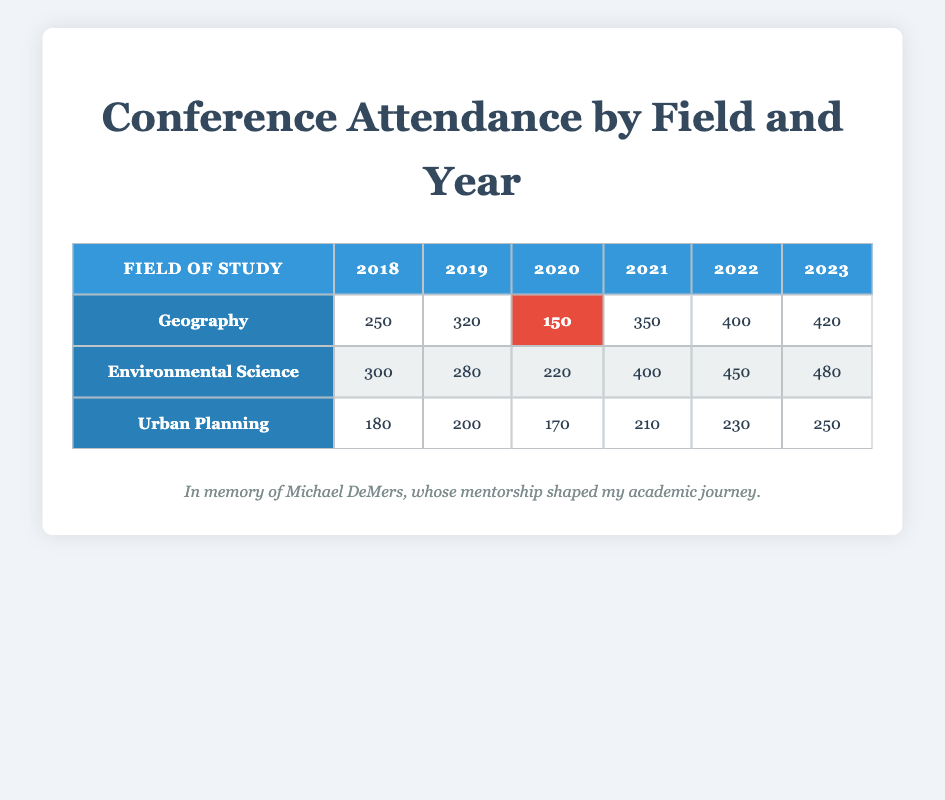What was the conference attendance for Geography in 2021? From the table, we can directly find the attendance for Geography in 2021 in the corresponding row and column which shows 350.
Answer: 350 In which year did Urban Planning have the lowest conference attendance? Looking through the Urban Planning row, we see the values are 180 (2018), 200 (2019), 170 (2020), 210 (2021), 230 (2022), and 250 (2023). The minimum value is 170, which occurs in 2020.
Answer: 2020 What is the total conference attendance for Environmental Science from 2018 to 2023? We need to add up the attendance for Environmental Science for each year: 300 (2018) + 280 (2019) + 220 (2020) + 400 (2021) + 450 (2022) + 480 (2023) = 2130.
Answer: 2130 Did the conference attendance for Geography increase from 2018 to 2022? We check the attendance values for Geography: 250 (2018), 320 (2019), 150 (2020), 350 (2021), and 400 (2022). The attendance decreased in 2020 but increased again in 2021 and 2022. Thus, it did increase from 2018 to 2022.
Answer: Yes Which field of study had the highest total attendance over the years 2018 to 2023? We calculate the total attendance for each field. For Geography: 250 + 320 + 150 + 350 + 400 + 420 = 1870. For Environmental Science: 300 + 280 + 220 + 400 + 450 + 480 = 2130. For Urban Planning: 180 + 200 + 170 + 210 + 230 + 250 = 1240. Environmental Science has the highest total of 2130.
Answer: Environmental Science What was the average conference attendance for Urban Planning from 2018 to 2023? The attendance for Urban Planning is 180 (2018), 200 (2019), 170 (2020), 210 (2021), 230 (2022), and 250 (2023). Summing these gives 180 + 200 + 170 + 210 + 230 + 250 = 1240. Dividing by 6 (the number of years) gives an average of 1240 / 6 = 206.67.
Answer: 206.67 Was the attendance for Environmental Science higher in 2023 compared to 2021? The attendance for Environmental Science in 2023 is 480 and in 2021 it is 400. Since 480 is greater than 400, attendance in 2023 is indeed higher.
Answer: Yes What was the maximum attendance recorded for any field in any year? We need to look for the maximum value across all fields and years. The highest number is 480 in the year 2023 for Environmental Science.
Answer: 480 